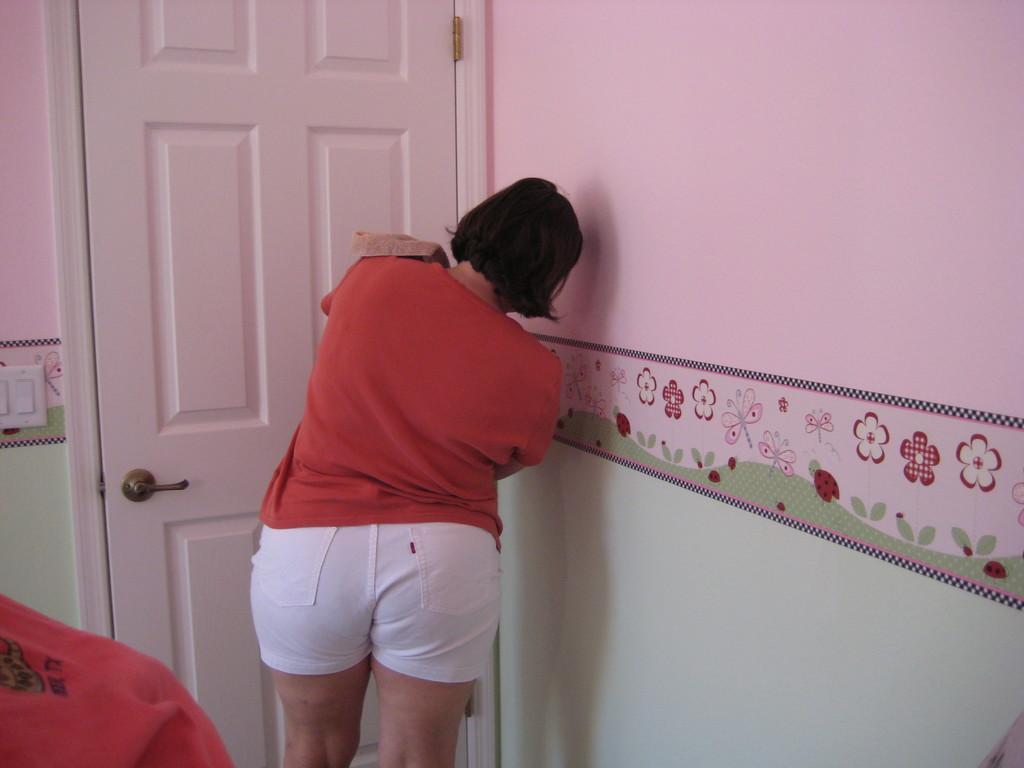Can you describe this image briefly? In this image there is a woman standing. In front of her there is a door to the wall. To the right there is a wall. There is a painting on the wall. To the left there are switches on the wall. 